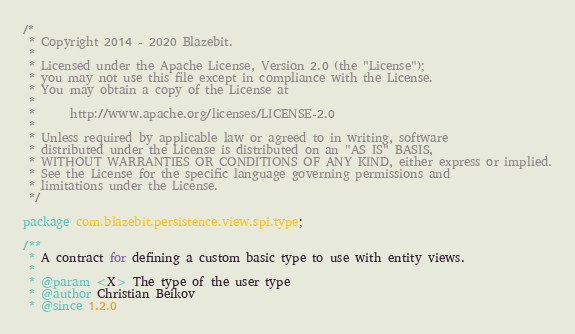Convert code to text. <code><loc_0><loc_0><loc_500><loc_500><_Java_>/*
 * Copyright 2014 - 2020 Blazebit.
 *
 * Licensed under the Apache License, Version 2.0 (the "License");
 * you may not use this file except in compliance with the License.
 * You may obtain a copy of the License at
 *
 *      http://www.apache.org/licenses/LICENSE-2.0
 *
 * Unless required by applicable law or agreed to in writing, software
 * distributed under the License is distributed on an "AS IS" BASIS,
 * WITHOUT WARRANTIES OR CONDITIONS OF ANY KIND, either express or implied.
 * See the License for the specific language governing permissions and
 * limitations under the License.
 */

package com.blazebit.persistence.view.spi.type;

/**
 * A contract for defining a custom basic type to use with entity views.
 *
 * @param <X> The type of the user type
 * @author Christian Beikov
 * @since 1.2.0</code> 